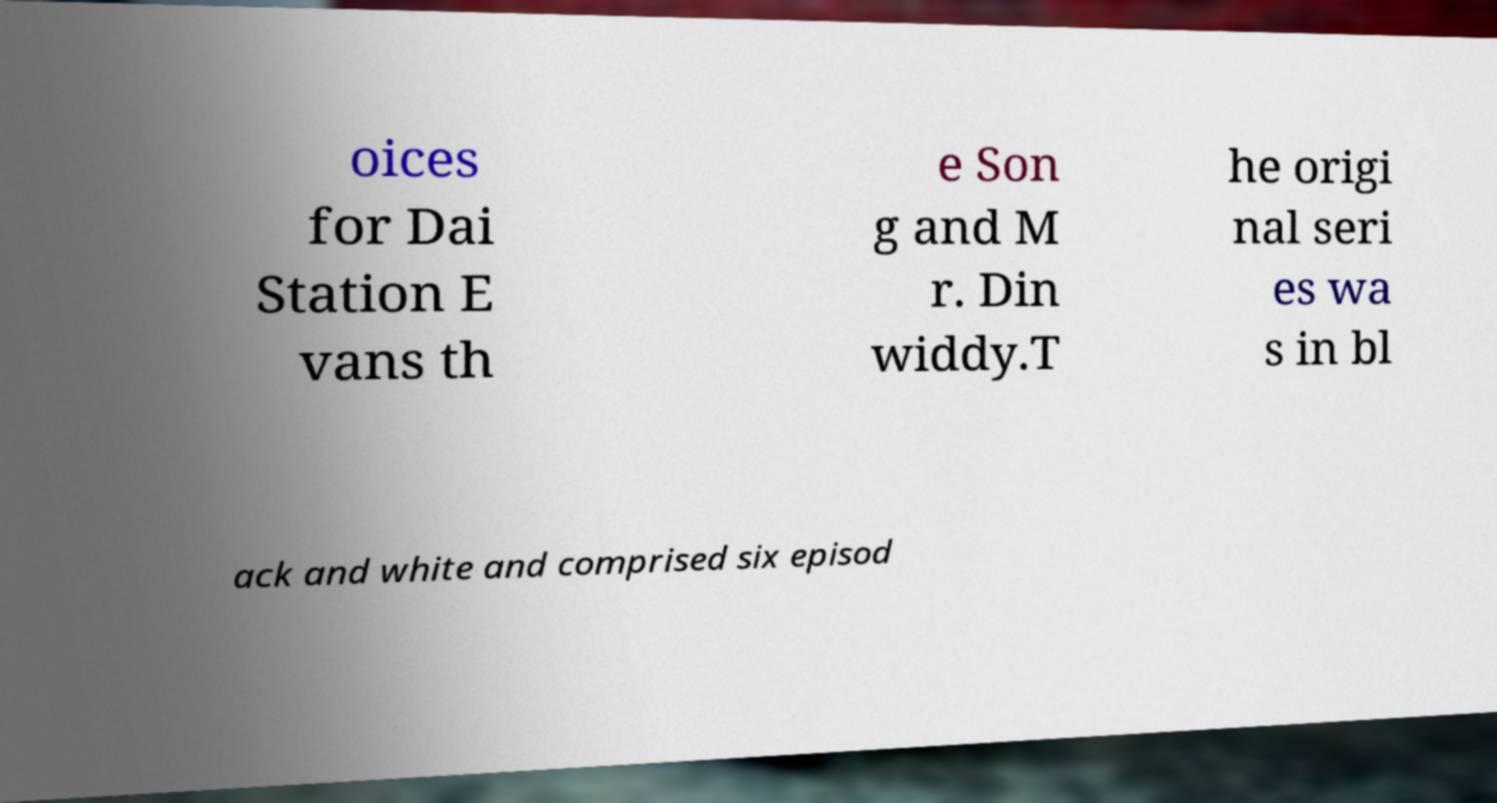There's text embedded in this image that I need extracted. Can you transcribe it verbatim? oices for Dai Station E vans th e Son g and M r. Din widdy.T he origi nal seri es wa s in bl ack and white and comprised six episod 